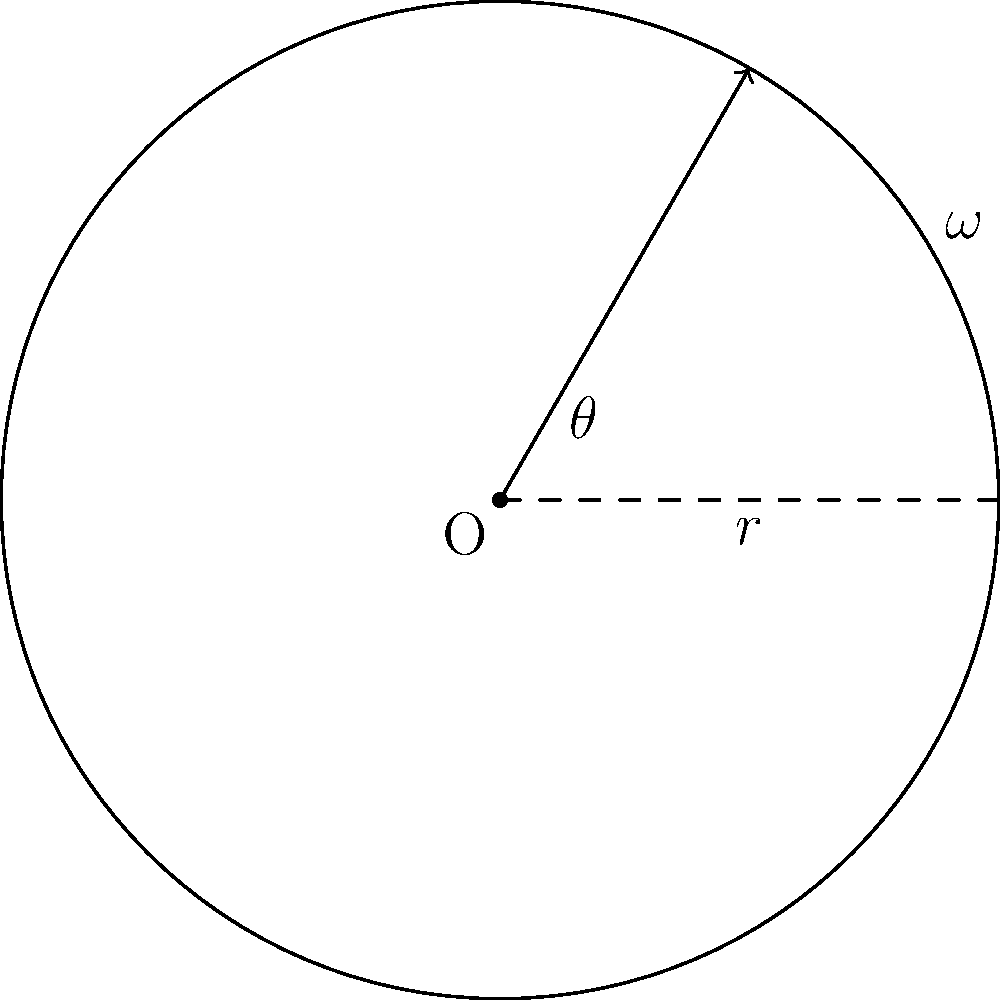During a snatch lift, a weightlifter's barbell follows a circular path. If the barbell completes a quarter rotation (90°) in 0.5 seconds and the radius of the circular path is 1.5 meters, calculate the angular velocity of the barbell in radians per second. To solve this problem, we'll follow these steps:

1) First, recall the formula for angular velocity:
   $$\omega = \frac{\Delta \theta}{\Delta t}$$
   where $\omega$ is angular velocity, $\Delta \theta$ is change in angle, and $\Delta t$ is change in time.

2) We're given:
   - $\Delta \theta = 90°$ (a quarter rotation)
   - $\Delta t = 0.5$ seconds

3) We need to convert the angle from degrees to radians:
   $$90° = 90 \cdot \frac{\pi}{180} = \frac{\pi}{2}$$ radians

4) Now we can substitute these values into our formula:
   $$\omega = \frac{\frac{\pi}{2}}{0.5}$$

5) Simplify:
   $$\omega = \pi$$ rad/s

Therefore, the angular velocity of the barbell is $\pi$ radians per second.
Answer: $\pi$ rad/s 